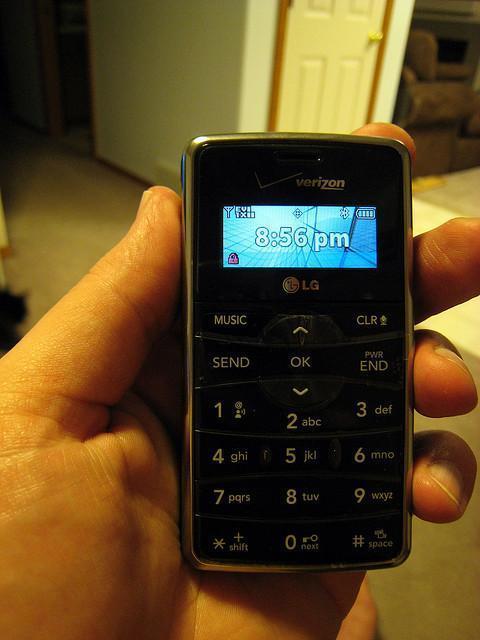How many people are visible?
Give a very brief answer. 1. 